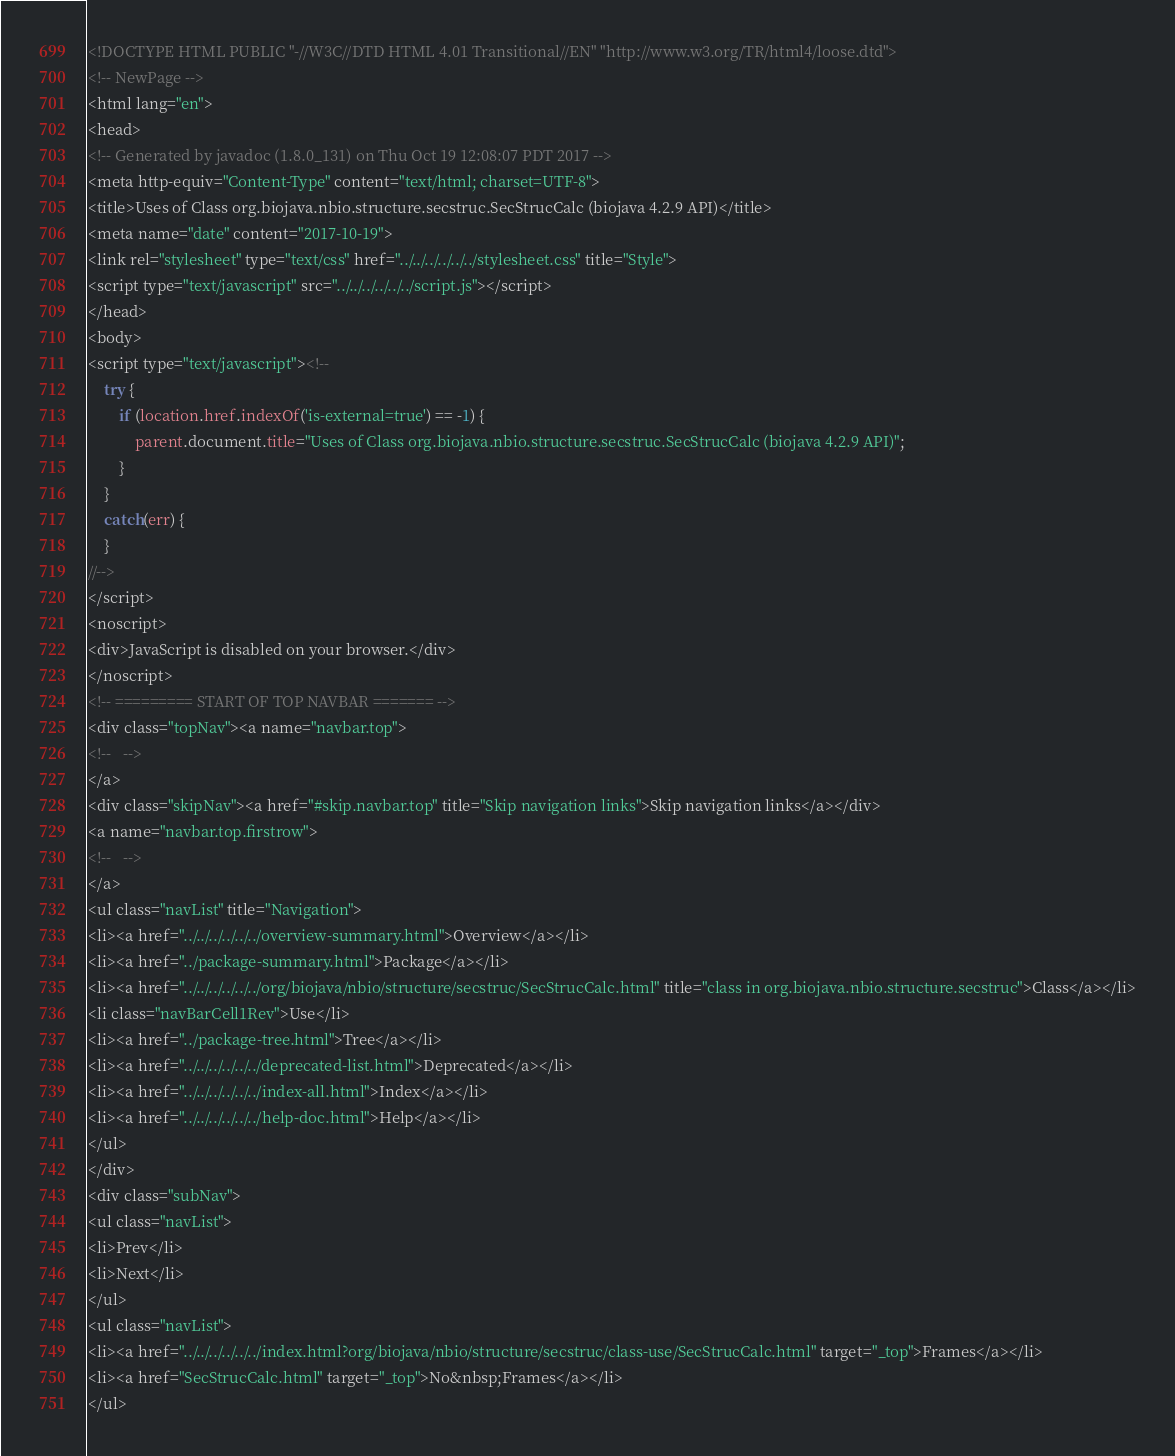Convert code to text. <code><loc_0><loc_0><loc_500><loc_500><_HTML_><!DOCTYPE HTML PUBLIC "-//W3C//DTD HTML 4.01 Transitional//EN" "http://www.w3.org/TR/html4/loose.dtd">
<!-- NewPage -->
<html lang="en">
<head>
<!-- Generated by javadoc (1.8.0_131) on Thu Oct 19 12:08:07 PDT 2017 -->
<meta http-equiv="Content-Type" content="text/html; charset=UTF-8">
<title>Uses of Class org.biojava.nbio.structure.secstruc.SecStrucCalc (biojava 4.2.9 API)</title>
<meta name="date" content="2017-10-19">
<link rel="stylesheet" type="text/css" href="../../../../../../stylesheet.css" title="Style">
<script type="text/javascript" src="../../../../../../script.js"></script>
</head>
<body>
<script type="text/javascript"><!--
    try {
        if (location.href.indexOf('is-external=true') == -1) {
            parent.document.title="Uses of Class org.biojava.nbio.structure.secstruc.SecStrucCalc (biojava 4.2.9 API)";
        }
    }
    catch(err) {
    }
//-->
</script>
<noscript>
<div>JavaScript is disabled on your browser.</div>
</noscript>
<!-- ========= START OF TOP NAVBAR ======= -->
<div class="topNav"><a name="navbar.top">
<!--   -->
</a>
<div class="skipNav"><a href="#skip.navbar.top" title="Skip navigation links">Skip navigation links</a></div>
<a name="navbar.top.firstrow">
<!--   -->
</a>
<ul class="navList" title="Navigation">
<li><a href="../../../../../../overview-summary.html">Overview</a></li>
<li><a href="../package-summary.html">Package</a></li>
<li><a href="../../../../../../org/biojava/nbio/structure/secstruc/SecStrucCalc.html" title="class in org.biojava.nbio.structure.secstruc">Class</a></li>
<li class="navBarCell1Rev">Use</li>
<li><a href="../package-tree.html">Tree</a></li>
<li><a href="../../../../../../deprecated-list.html">Deprecated</a></li>
<li><a href="../../../../../../index-all.html">Index</a></li>
<li><a href="../../../../../../help-doc.html">Help</a></li>
</ul>
</div>
<div class="subNav">
<ul class="navList">
<li>Prev</li>
<li>Next</li>
</ul>
<ul class="navList">
<li><a href="../../../../../../index.html?org/biojava/nbio/structure/secstruc/class-use/SecStrucCalc.html" target="_top">Frames</a></li>
<li><a href="SecStrucCalc.html" target="_top">No&nbsp;Frames</a></li>
</ul></code> 